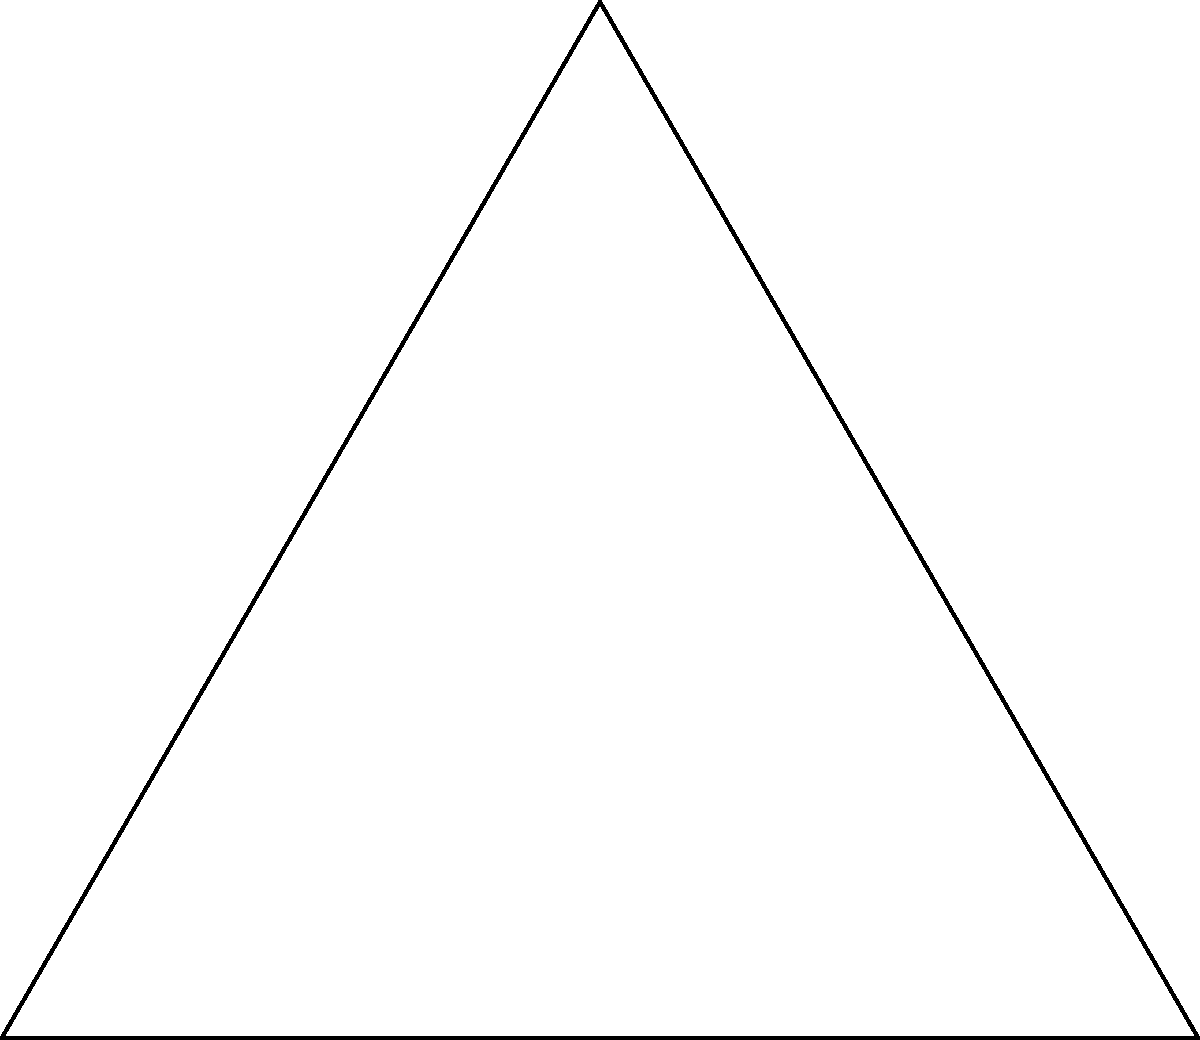In the context of designing bio-compatible energy storage devices, you need to optimize the surface area-to-volume ratio of a circular component inscribed within a triangular housing. Given an equilateral triangle with side length $a$, determine the radius $r$ of the inscribed circle in terms of $a$. How does this relationship impact the efficiency of energy storage and regulatory compliance? Let's approach this step-by-step:

1) In an equilateral triangle, the radius of the inscribed circle is related to the side length. We'll derive this relationship.

2) Consider the right triangle formed by the center of the inscribed circle, the midpoint of a side, and a vertex of the equilateral triangle.

3) The radius $r$ is the short leg of this right triangle.

4) The long leg is half the side length: $\frac{a}{2}$.

5) The hypotenuse is the distance from the center to a vertex, which we can call $R$.

6) Using the Pythagorean theorem:

   $$R^2 = r^2 + (\frac{a}{2})^2$$

7) In an equilateral triangle, $R = \frac{a}{\sqrt{3}}$. Substituting this:

   $$(\frac{a}{\sqrt{3}})^2 = r^2 + (\frac{a}{2})^2$$

8) Simplifying:

   $$\frac{a^2}{3} = r^2 + \frac{a^2}{4}$$

9) Solving for $r$:

   $$r^2 = \frac{a^2}{3} - \frac{a^2}{4} = \frac{4a^2 - 3a^2}{12} = \frac{a^2}{12}$$

   $$r = \frac{a}{2\sqrt{3}}$$

This relationship impacts energy storage efficiency and regulatory compliance:

1) Surface area-to-volume ratio: A larger ratio generally allows for more efficient energy transfer. The ratio here is $\frac{2\pi r}{2\pi r^2} = \frac{1}{r} = \frac{2\sqrt{3}}{a}$.

2) Material usage: The relationship helps optimize material use, potentially reducing costs and environmental impact.

3) Thermal management: The geometry affects heat dissipation, crucial for safety and performance in energy storage devices.

4) Structural integrity: The relationship ensures the component fits securely within the housing, meeting safety regulations.

5) Scalability: Understanding this relationship allows for consistent scaling of designs, maintaining performance across different sizes.
Answer: $r = \frac{a}{2\sqrt{3}}$ 